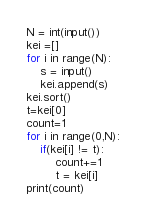Convert code to text. <code><loc_0><loc_0><loc_500><loc_500><_Python_>N = int(input())
kei =[]
for i in range(N):
    s = input()
    kei.append(s)
kei.sort()
t=kei[0]
count=1
for i in range(0,N):
    if(kei[i] != t):
        count+=1
        t = kei[i]
print(count)</code> 